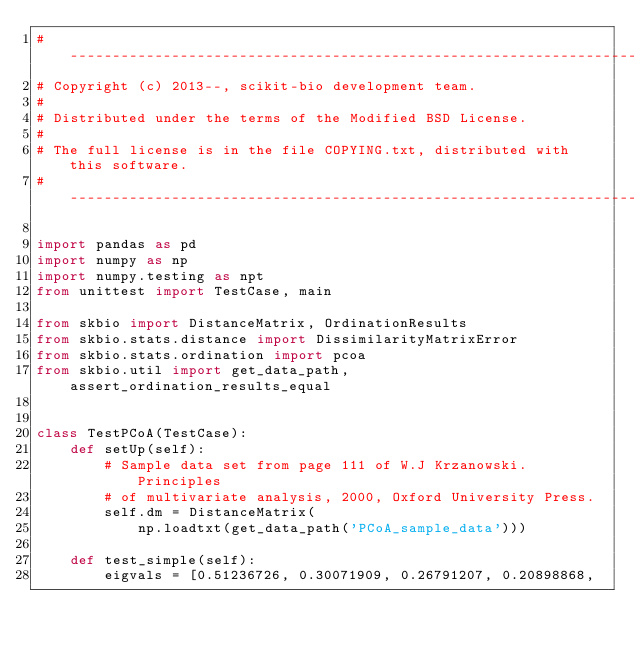<code> <loc_0><loc_0><loc_500><loc_500><_Python_># ----------------------------------------------------------------------------
# Copyright (c) 2013--, scikit-bio development team.
#
# Distributed under the terms of the Modified BSD License.
#
# The full license is in the file COPYING.txt, distributed with this software.
# ----------------------------------------------------------------------------

import pandas as pd
import numpy as np
import numpy.testing as npt
from unittest import TestCase, main

from skbio import DistanceMatrix, OrdinationResults
from skbio.stats.distance import DissimilarityMatrixError
from skbio.stats.ordination import pcoa
from skbio.util import get_data_path, assert_ordination_results_equal


class TestPCoA(TestCase):
    def setUp(self):
        # Sample data set from page 111 of W.J Krzanowski. Principles
        # of multivariate analysis, 2000, Oxford University Press.
        self.dm = DistanceMatrix(
            np.loadtxt(get_data_path('PCoA_sample_data')))

    def test_simple(self):
        eigvals = [0.51236726, 0.30071909, 0.26791207, 0.20898868,</code> 